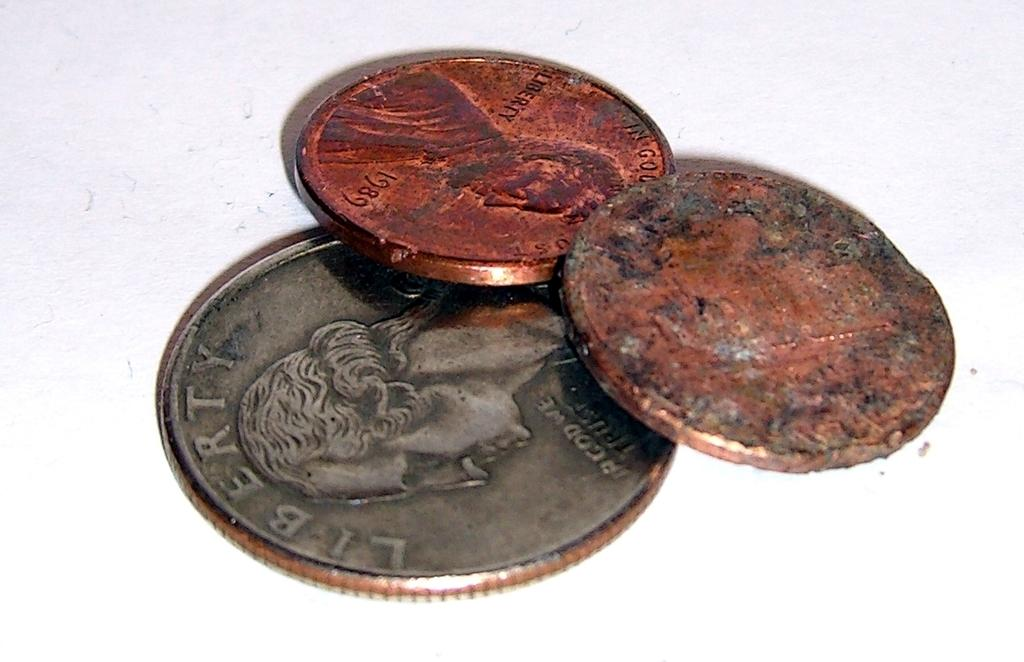<image>
Give a short and clear explanation of the subsequent image. two pennies on top of a quarter that says 'liberty' at the top of it 